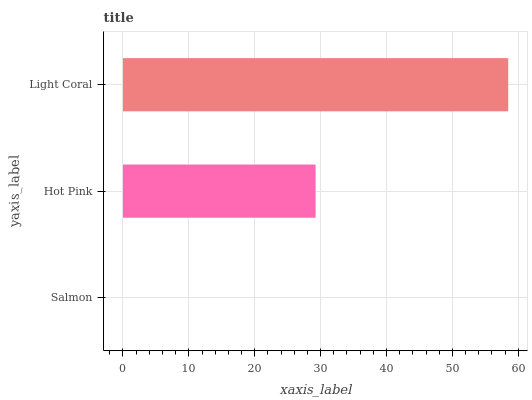Is Salmon the minimum?
Answer yes or no. Yes. Is Light Coral the maximum?
Answer yes or no. Yes. Is Hot Pink the minimum?
Answer yes or no. No. Is Hot Pink the maximum?
Answer yes or no. No. Is Hot Pink greater than Salmon?
Answer yes or no. Yes. Is Salmon less than Hot Pink?
Answer yes or no. Yes. Is Salmon greater than Hot Pink?
Answer yes or no. No. Is Hot Pink less than Salmon?
Answer yes or no. No. Is Hot Pink the high median?
Answer yes or no. Yes. Is Hot Pink the low median?
Answer yes or no. Yes. Is Light Coral the high median?
Answer yes or no. No. Is Salmon the low median?
Answer yes or no. No. 